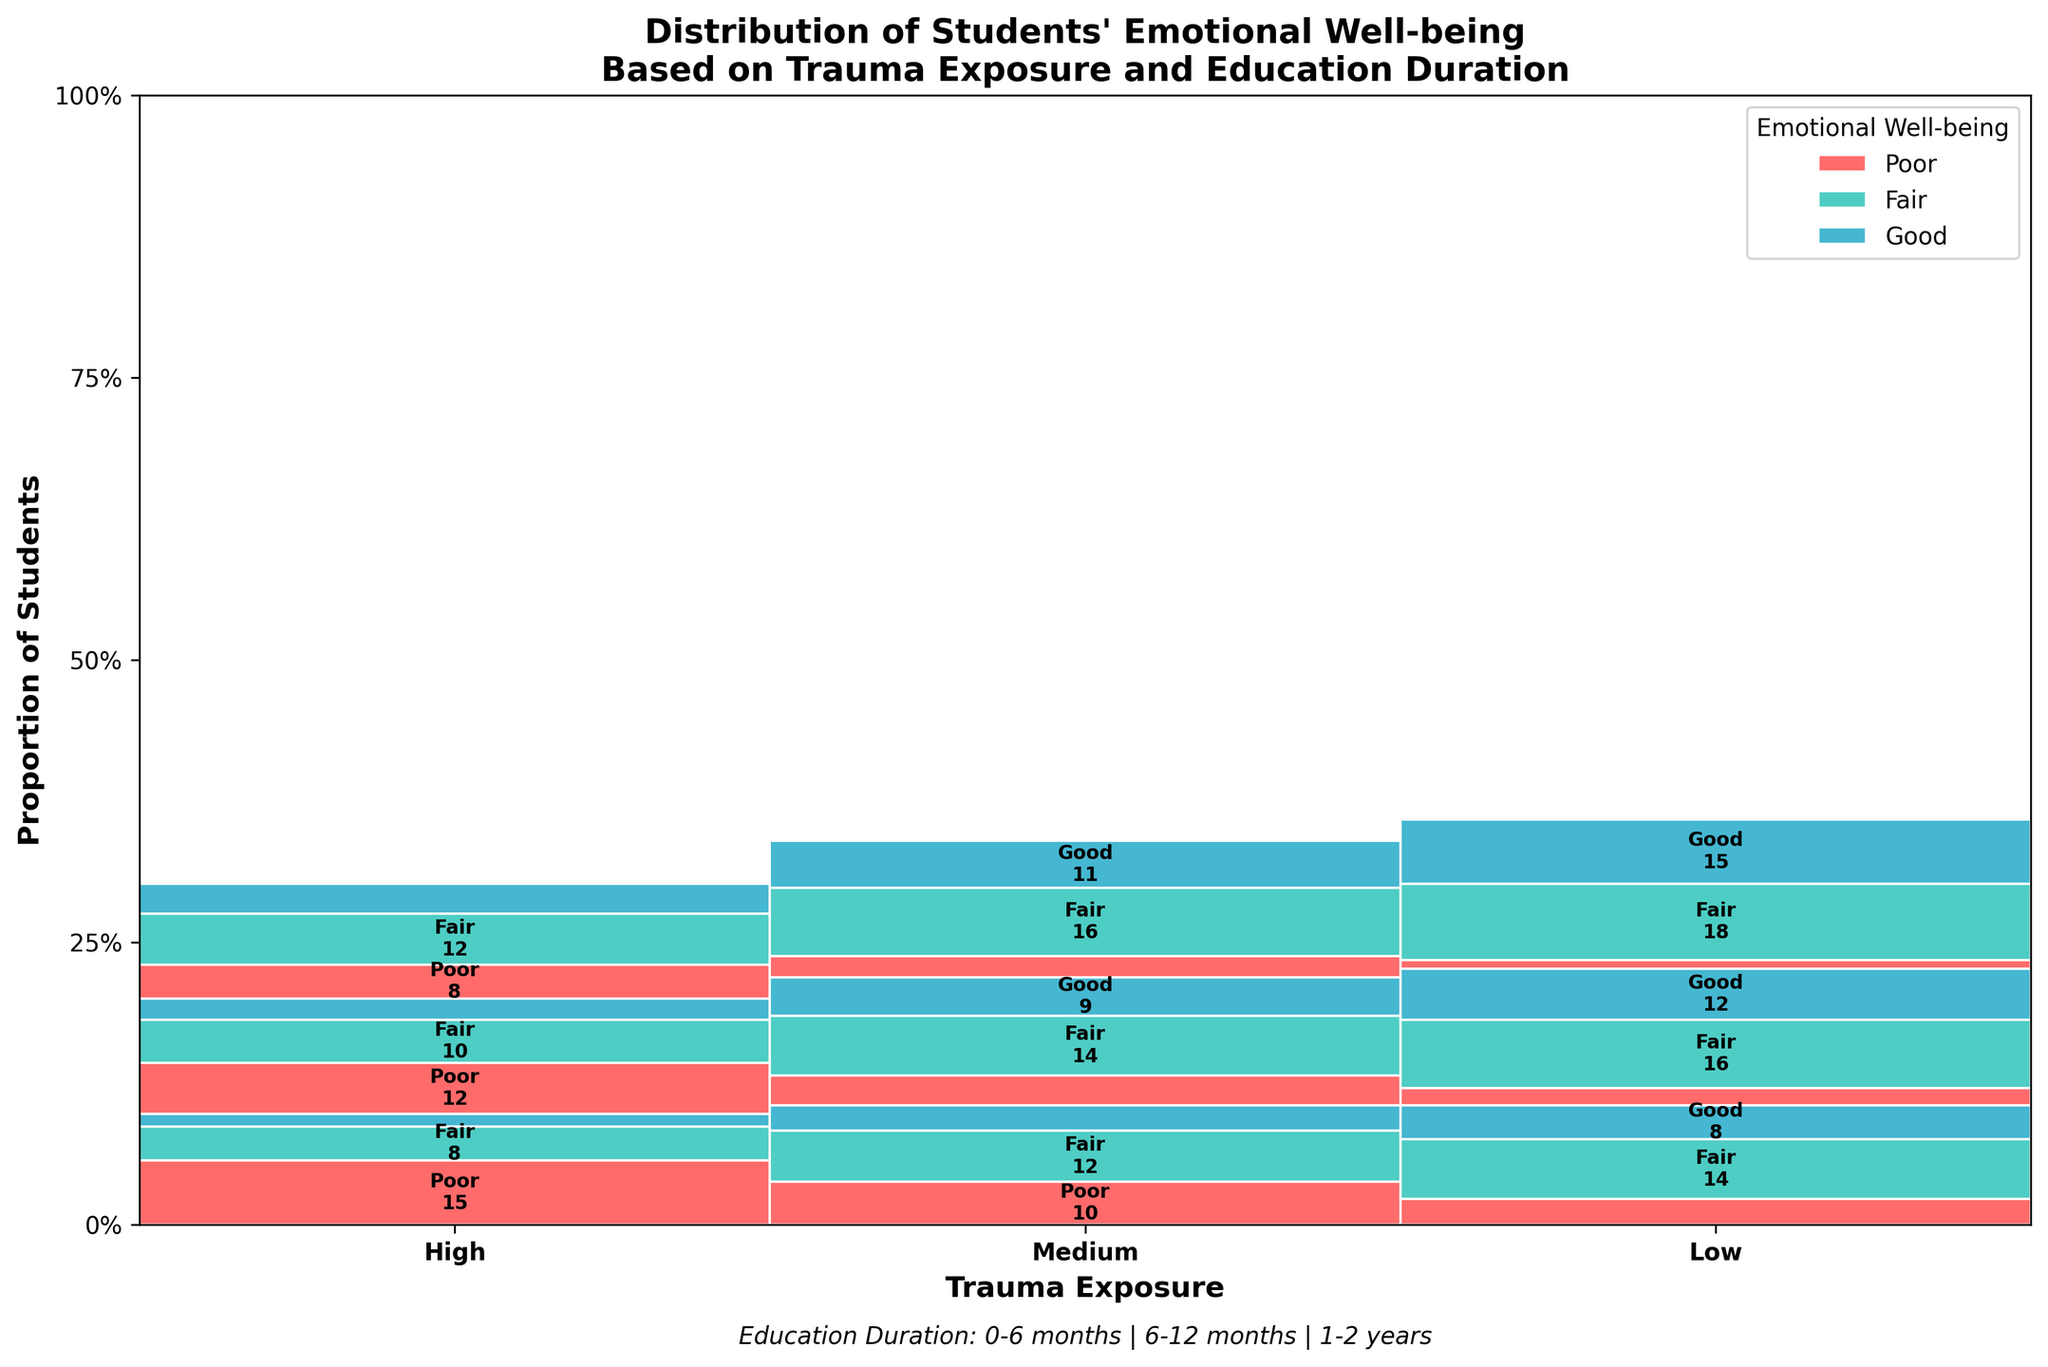What are the three levels of trauma exposure shown in the plot? The title indicates that the plot shows the distribution of emotional well-being based on trauma exposure. The x-axis labels show three distinct trauma exposure levels.
Answer: High, Medium, Low What is the proportion of students with "Poor" emotional well-being for those with "Low" trauma exposure and "1-2 years" education duration? Identify the "Low" trauma exposure section and then look for the "1-2 years" education duration. The height of the "Poor" emotional well-being section is visually very small.
Answer: 2% How does the proportion of students with "Good" emotional well-being change from "0-6 months" to "1-2 years" in "High" trauma exposure? Compare sections within the "High" trauma exposure area for "Good" well-being, identify changes in the height of these sections from "0-6 months" to "1-2 years".
Answer: Increases from 3 to 7 Which trauma exposure level has the highest proportion of students with "Fair" emotional well-being for "6-12 months" education duration? Compare the heights of the "Fair" emotional well-being sections within "6-12 months" education duration for all three trauma exposure levels.
Answer: Low What is the distribution of emotional well-being for students with "Medium" trauma exposure and "0-6 months" education duration? Examine the "Medium" trauma exposure section for the "0-6 months" education duration and note the counts within each emotional well-being category.
Answer: 10 Poor, 12 Fair, 6 Good Are there more students with "Fair" emotional well-being in the "6-12 months" education duration with "High" trauma exposure or "Medium" trauma exposure? Compare the sections of "Fair" emotional well-being under "6-12 months" education duration for "High" and "Medium" trauma exposure based on the counts provided.
Answer: Medium (14) For students with "Low" trauma exposure, how does the distribution of emotional well-being change as education duration increases? Examine the "Low" trauma exposure sections across "0-6 months", "6-12 months", and "1-2 years" education durations, and note changes in all three emotional well-being categories.
Answer: Proportion of "Good" increases, "Fair" increases, and "Poor" decreases What is the total proportion of students with "Poor" emotional well-being across all trauma exposure and education duration categories? Sum up the proportions of "Poor" emotional well-being from all sections in the plot divided by the total students.
Answer: [Detailed Calculation Needed] 